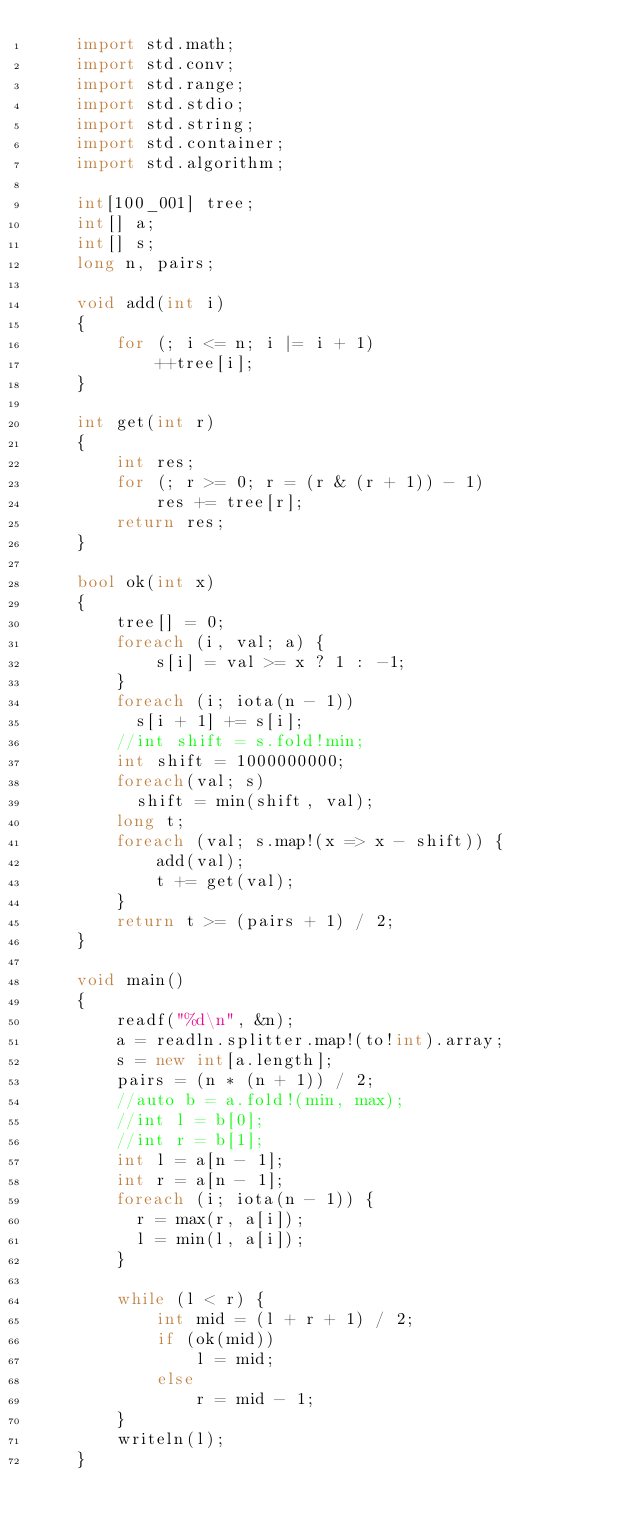<code> <loc_0><loc_0><loc_500><loc_500><_D_>    import std.math;
    import std.conv;
    import std.range;
    import std.stdio;
    import std.string;
    import std.container;
    import std.algorithm;
     
    int[100_001] tree;
    int[] a;
    int[] s;
    long n, pairs;
     
    void add(int i)
    {
        for (; i <= n; i |= i + 1)
            ++tree[i];
    }
     
    int get(int r)
    {
        int res;
        for (; r >= 0; r = (r & (r + 1)) - 1)
            res += tree[r];
        return res;
    }
     
    bool ok(int x)
    {
        tree[] = 0;
        foreach (i, val; a) {
            s[i] = val >= x ? 1 : -1;
        }
        foreach (i; iota(n - 1))
          s[i + 1] += s[i];
        //int shift = s.fold!min;
        int shift = 1000000000;
        foreach(val; s)
          shift = min(shift, val);
        long t;
        foreach (val; s.map!(x => x - shift)) {
            add(val);
            t += get(val);
        }
        return t >= (pairs + 1) / 2;
    }
     
    void main()
    {
        readf("%d\n", &n);
        a = readln.splitter.map!(to!int).array;
        s = new int[a.length];
        pairs = (n * (n + 1)) / 2;
        //auto b = a.fold!(min, max);
        //int l = b[0];
        //int r = b[1];
        int l = a[n - 1];
        int r = a[n - 1];
        foreach (i; iota(n - 1)) {
          r = max(r, a[i]);
          l = min(l, a[i]);
        }
        
        while (l < r) {
            int mid = (l + r + 1) / 2;
            if (ok(mid))
                l = mid;
            else
                r = mid - 1;
        }
        writeln(l);
    }
</code> 